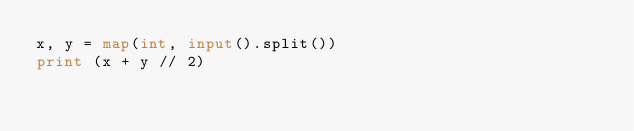<code> <loc_0><loc_0><loc_500><loc_500><_Python_>x, y = map(int, input().split())
print (x + y // 2)</code> 